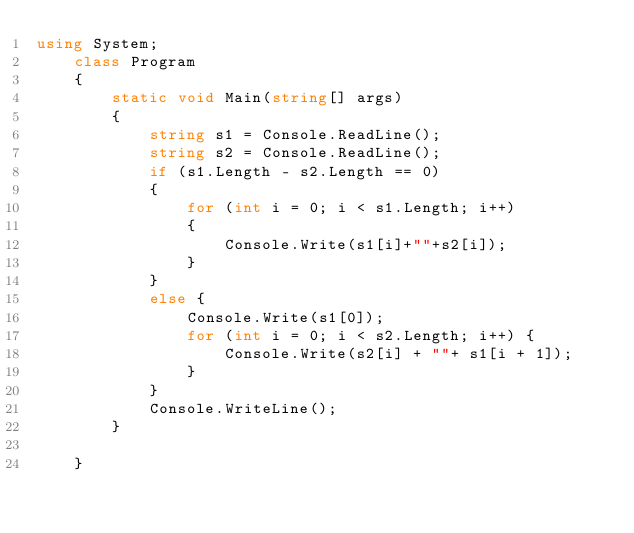Convert code to text. <code><loc_0><loc_0><loc_500><loc_500><_C#_>using System;
    class Program
    {
        static void Main(string[] args)
        {
            string s1 = Console.ReadLine();
            string s2 = Console.ReadLine();
            if (s1.Length - s2.Length == 0)
            {
                for (int i = 0; i < s1.Length; i++)
                {
                    Console.Write(s1[i]+""+s2[i]);
                }
            }
            else {
                Console.Write(s1[0]);
                for (int i = 0; i < s2.Length; i++) {
                    Console.Write(s2[i] + ""+ s1[i + 1]);
                }
            }
            Console.WriteLine();
        }
        
    }
</code> 